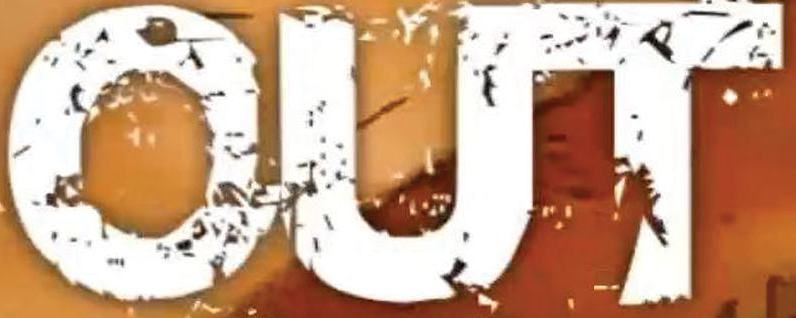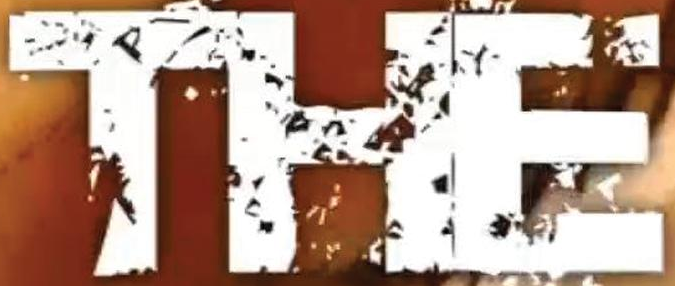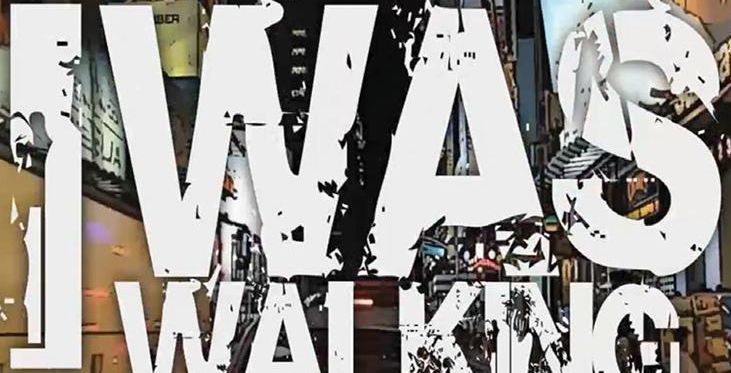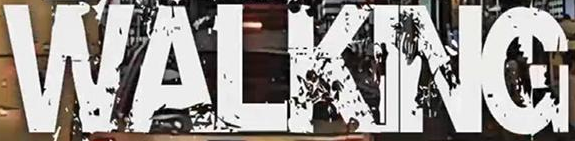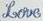What text appears in these images from left to right, separated by a semicolon? OUT; THE; IWAS; WALKING; Love 